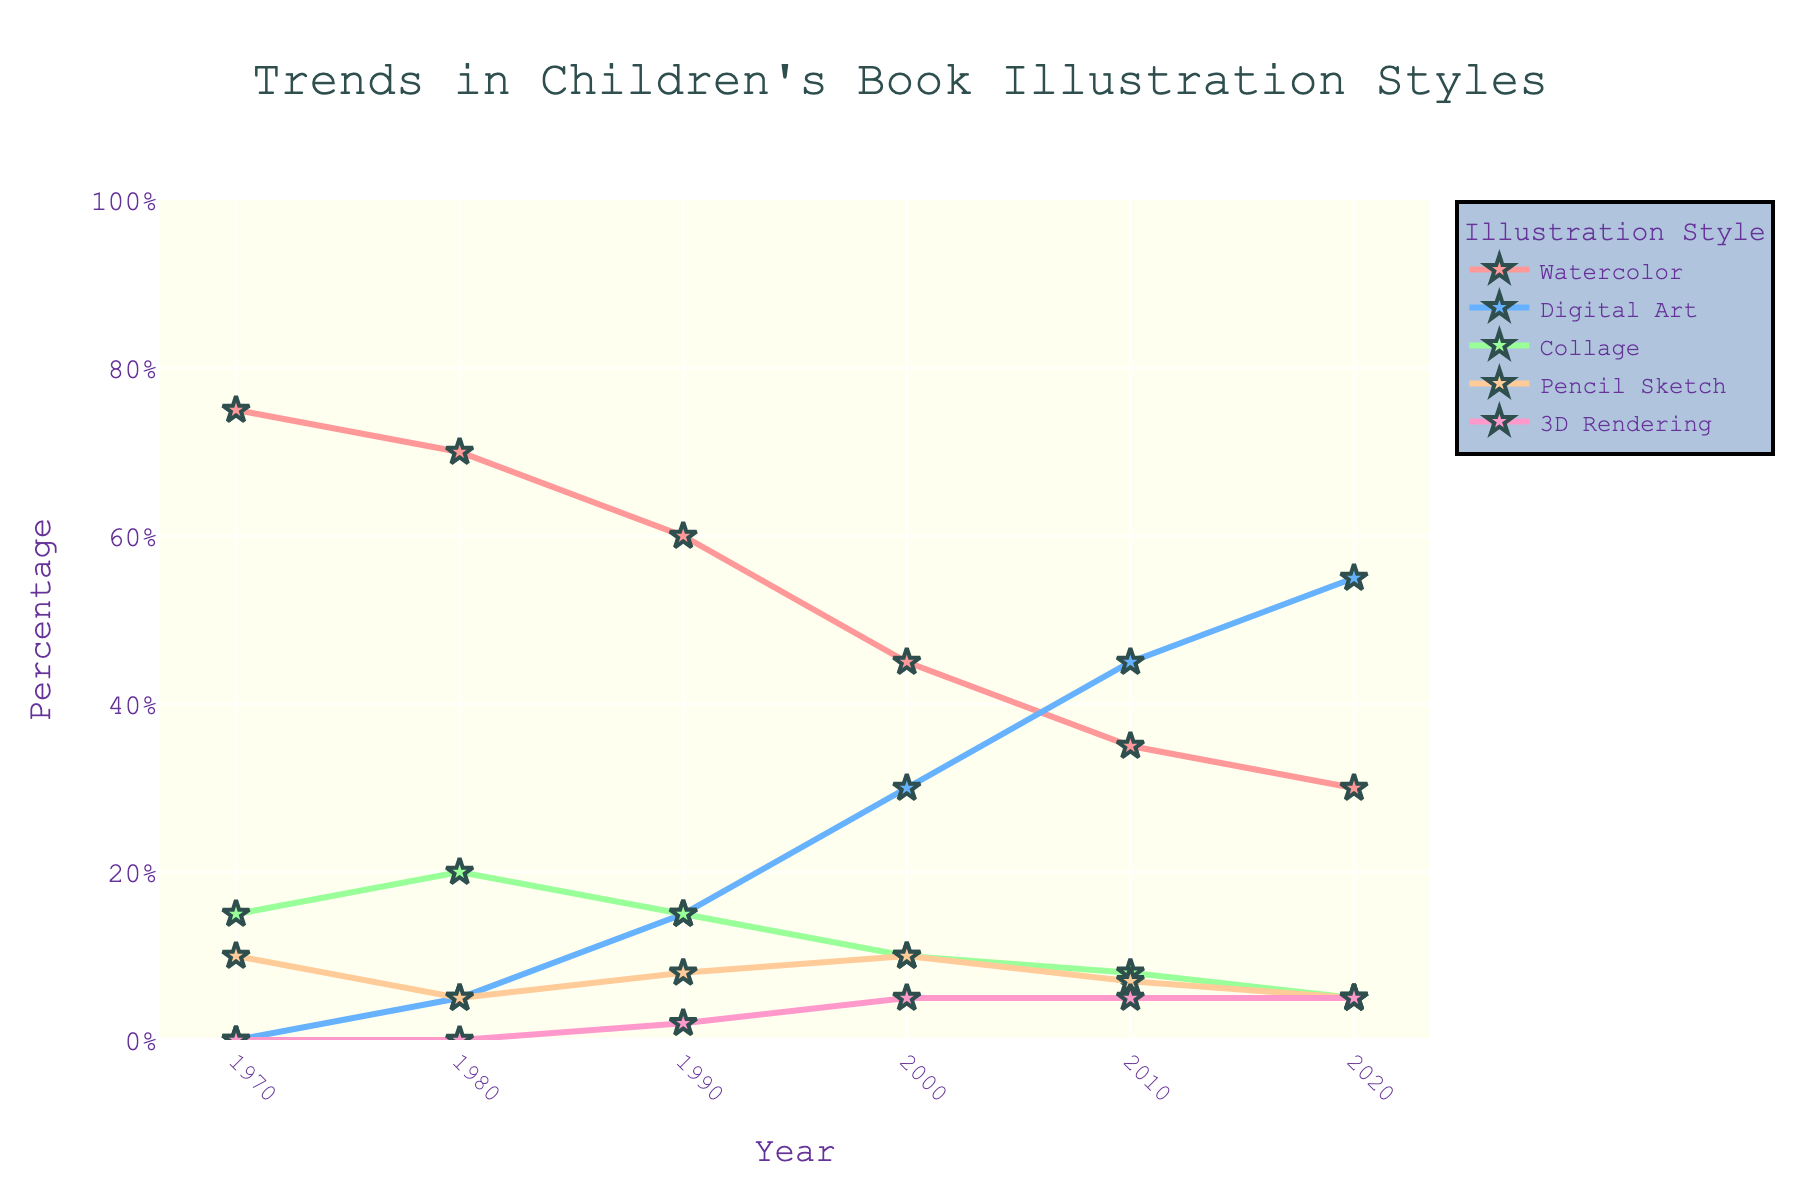How did the percentage of Watercolor illustrations change from 1970 to 2020? In 1970, the percentage of Watercolor illustrations was 75%. In 2020, it was 30%. The change is calculated as 75% - 30% = 45%.
Answer: 45% Which illustration style increased the most between 1970 and 2020? In 1970, Digital Art was at 0% and increased to 55% in 2020. This is an increase of 55%.
Answer: Digital Art How did the total percentage among all styles in 1980 compare to 2000? In 1980, the percentages are: 70 (Watercolor) + 5 (Digital Art) + 20 (Collage) + 5 (Pencil Sketch) + 0 (3D Rendering) = 100. In 2000, the percentages are: 45 (Watercolor) + 30 (Digital Art) + 10 (Collage) + 10 (Pencil Sketch) + 5 (3D Rendering) = 100. Both years sum to 100%.
Answer: They are equal Which year saw the biggest decrease in Watercolor illustrations? The largest decrease in the percentage of Watercolor illustrations is from 1990 (60%) to 2000 (45%), a difference of 15%.
Answer: 2000 Compare the percentages of Digital Art and Pencil Sketch in 2010. Which one is higher and by how much? In 2010, Digital Art is 45% and Pencil Sketch is 7%. The difference is 45% - 7% = 38%.
Answer: Digital Art by 38% What is the average percentage of Collage illustrations over the 50-year period? The percentages of Collage illustrations are: 15 (1970), 20 (1980), 15 (1990), 10 (2000), 8 (2010), and 5 (2020). The sum is 15 + 20 + 15 + 10 + 8 + 5 = 73. The average is 73 / 6 ≈ 12.17%.
Answer: 12.17% By how much did the percentage of 3D Rendering change between 1990 and 2020? In 1990, the percentage of 3D Rendering was 2%. In 2020, it was 5%. The change is 5% - 2% = 3%.
Answer: 3% Which illustration style had the most stable percentage over the 50-year period? 3D Rendering percentages are: 0 (1970), 0 (1980), 2 (1990), 5 (2000), 5 (2010), and 5 (2020). The variance is minimal compared to other styles.
Answer: 3D Rendering What is the trend for Pencil Sketch illustrations from 1970 to 2020? The percentage starts at 10% in 1970, slightly fluctuates and decreases to 5% in 2020.
Answer: Decreasing 